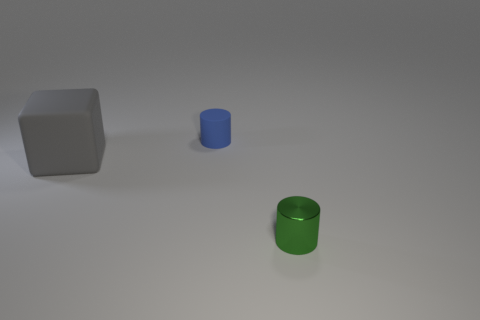Is there anything else that is the same size as the gray block?
Ensure brevity in your answer.  No. What number of green shiny objects are left of the blue matte cylinder?
Offer a terse response. 0. Is the number of tiny yellow cylinders greater than the number of green metal cylinders?
Your answer should be compact. No. What shape is the object that is to the right of the big gray rubber cube and in front of the rubber cylinder?
Your response must be concise. Cylinder. Are any tiny gray matte objects visible?
Provide a succinct answer. No. What is the material of the tiny green thing that is the same shape as the blue rubber thing?
Make the answer very short. Metal. There is a large thing that is behind the small cylinder that is in front of the object that is behind the big rubber thing; what is its shape?
Provide a succinct answer. Cube. What number of other tiny shiny objects have the same shape as the small green metallic object?
Keep it short and to the point. 0. Does the thing in front of the gray object have the same color as the tiny thing that is to the left of the small green cylinder?
Offer a very short reply. No. There is another object that is the same size as the green metallic thing; what is it made of?
Your response must be concise. Rubber. 